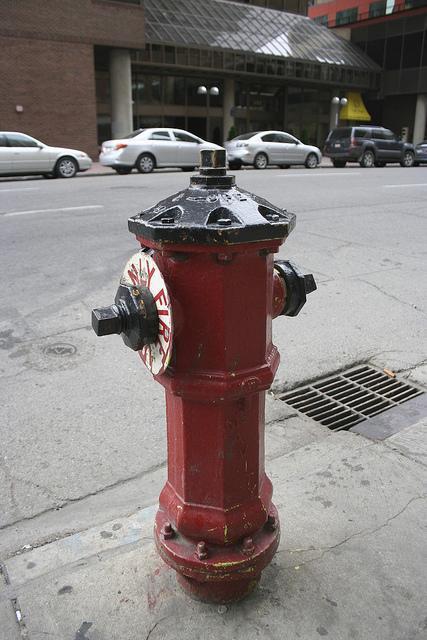How many black parts are on the fire hydrant?
Give a very brief answer. 3. How many cars are visible?
Give a very brief answer. 4. How many cars are in the picture?
Give a very brief answer. 4. 